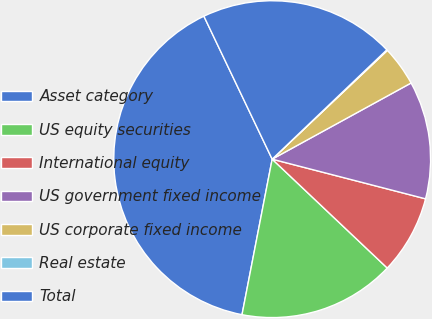Convert chart to OTSL. <chart><loc_0><loc_0><loc_500><loc_500><pie_chart><fcel>Asset category<fcel>US equity securities<fcel>International equity<fcel>US government fixed income<fcel>US corporate fixed income<fcel>Real estate<fcel>Total<nl><fcel>39.86%<fcel>15.99%<fcel>8.03%<fcel>12.01%<fcel>4.06%<fcel>0.08%<fcel>19.97%<nl></chart> 